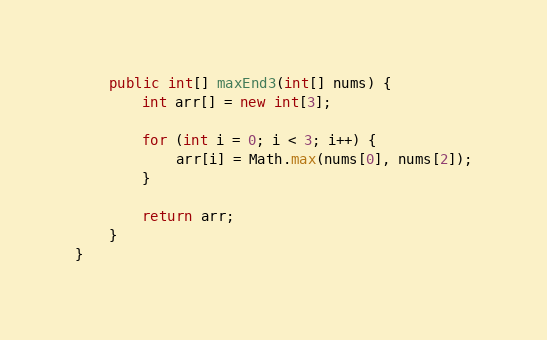<code> <loc_0><loc_0><loc_500><loc_500><_Java_>    public int[] maxEnd3(int[] nums) {
        int arr[] = new int[3];

        for (int i = 0; i < 3; i++) {
            arr[i] = Math.max(nums[0], nums[2]);
        }

        return arr;
    }
}
</code> 